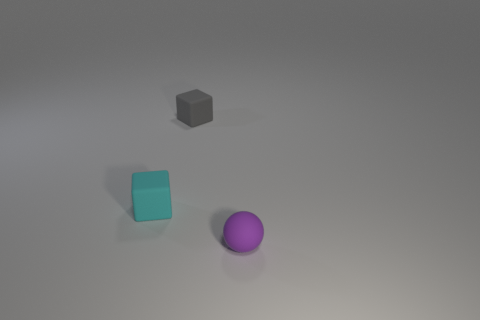What are the colors of the objects present? The objects present consist of a cyan cube, a gray block, and a purple sphere, each with their distinct colors. 